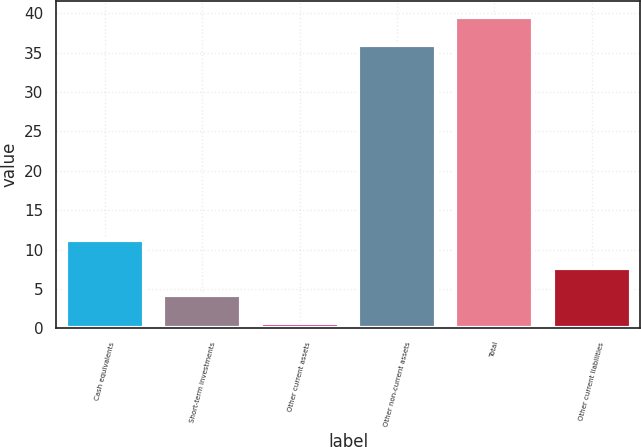Convert chart. <chart><loc_0><loc_0><loc_500><loc_500><bar_chart><fcel>Cash equivalents<fcel>Short-term investments<fcel>Other current assets<fcel>Other non-current assets<fcel>Total<fcel>Other current liabilities<nl><fcel>11.25<fcel>4.17<fcel>0.63<fcel>36<fcel>39.54<fcel>7.71<nl></chart> 